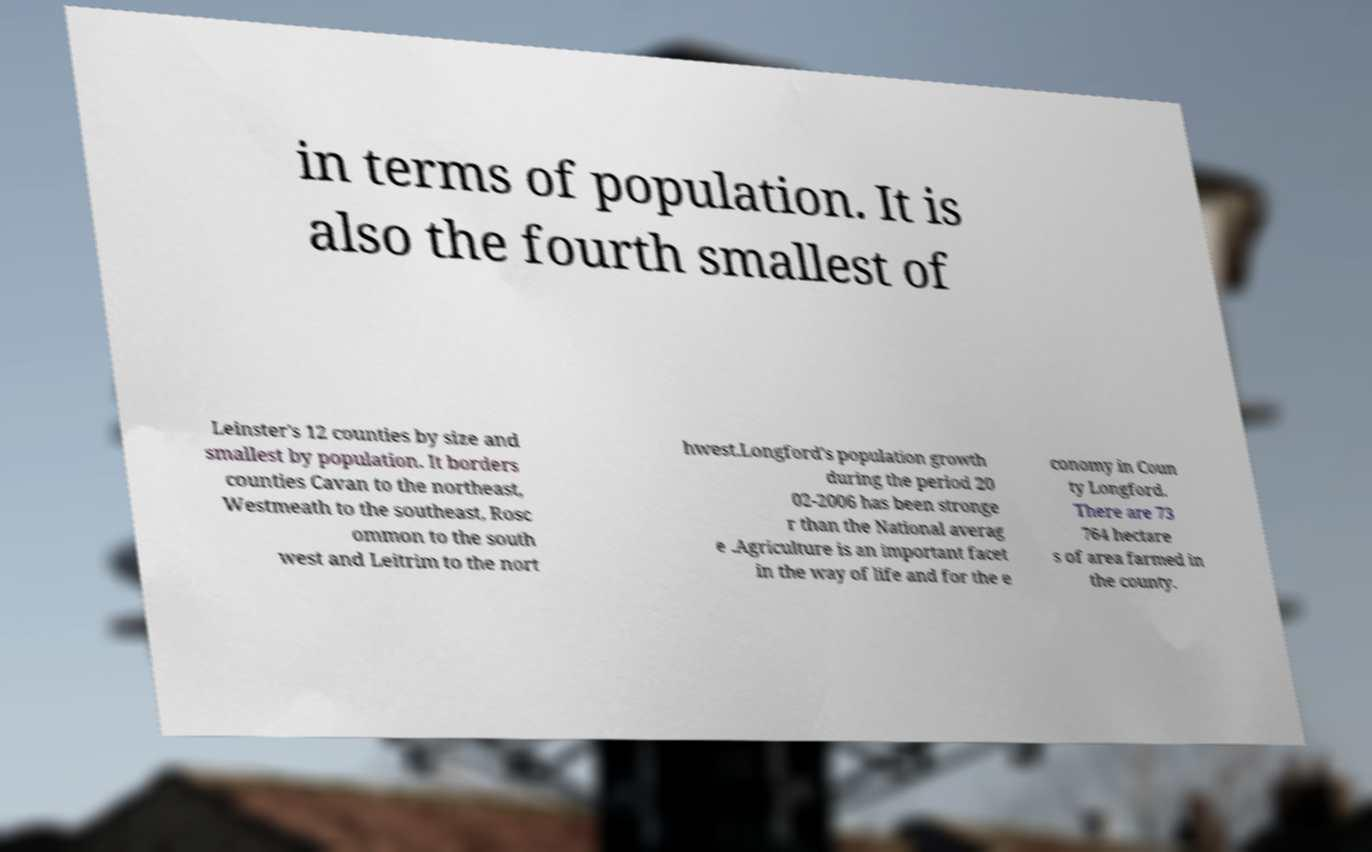Please read and relay the text visible in this image. What does it say? in terms of population. It is also the fourth smallest of Leinster's 12 counties by size and smallest by population. It borders counties Cavan to the northeast, Westmeath to the southeast, Rosc ommon to the south west and Leitrim to the nort hwest.Longford's population growth during the period 20 02-2006 has been stronge r than the National averag e .Agriculture is an important facet in the way of life and for the e conomy in Coun ty Longford. There are 73 764 hectare s of area farmed in the county. 